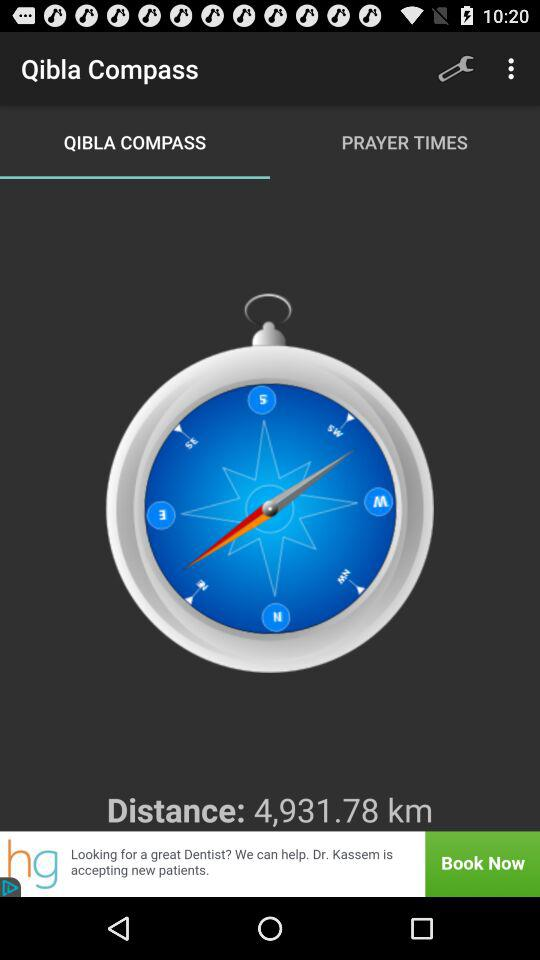Which tab is selected? The selected tab is "QIBLA COMPASS". 